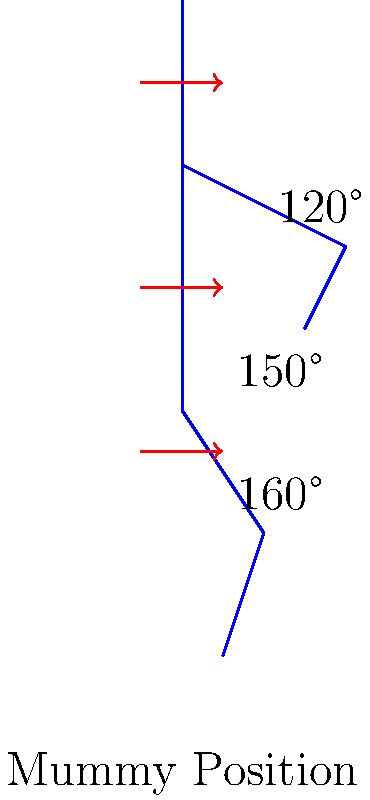In the mummification process, the body is typically positioned with specific joint angles to ensure proper preservation. Based on the diagram, what is the approximate angle of the elbow joint in a typical mummy position, and how does this positioning contribute to the overall preservation process? To answer this question, let's break it down step-by-step:

1. Observe the diagram: The diagram shows a simplified representation of a mummy's body position, with joint angles marked at key points.

2. Identify the elbow joint: The elbow joint is located where the upper arm meets the forearm, shown in the diagram with an angle measurement.

3. Read the elbow joint angle: The diagram indicates that the elbow joint angle is approximately 120°.

4. Understand the significance of this angle:
   a) A 120° angle at the elbow keeps the arms close to the body, reducing the overall volume of the mummy.
   b) This position helps in wrapping the body tightly with linen bandages, a crucial step in mummification.
   c) The compact positioning aids in the even distribution of natron (drying agent) around the body during the desiccation process.

5. Consider the preservation benefits:
   a) Reduced volume minimizes exposure to air, slowing decomposition.
   b) Tight wrapping and compact positioning help maintain the body's shape during the drying process.
   c) Even distribution of natron ensures thorough dehydration, which is essential for long-term preservation.

6. Compare to other joints: Note that other joints, like the knee (160°) and hip (150°), are also positioned at specific angles to achieve optimal preservation.

The 120° angle at the elbow, combined with the positioning of other joints, creates an overall compact form that facilitates efficient mummification and long-term preservation of the body.
Answer: 120°; facilitates compact wrapping and even desiccation 